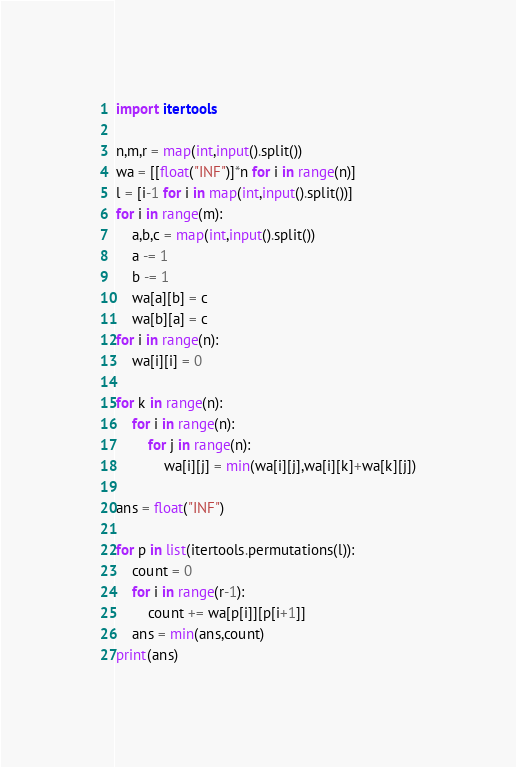<code> <loc_0><loc_0><loc_500><loc_500><_Python_>import itertools

n,m,r = map(int,input().split())
wa = [[float("INF")]*n for i in range(n)]
l = [i-1 for i in map(int,input().split())]
for i in range(m):
    a,b,c = map(int,input().split())
    a -= 1
    b -= 1
    wa[a][b] = c
    wa[b][a] = c
for i in range(n):
    wa[i][i] = 0

for k in range(n):
    for i in range(n):
        for j in range(n):
            wa[i][j] = min(wa[i][j],wa[i][k]+wa[k][j])

ans = float("INF")

for p in list(itertools.permutations(l)):
    count = 0
    for i in range(r-1):
        count += wa[p[i]][p[i+1]]
    ans = min(ans,count)
print(ans)

</code> 